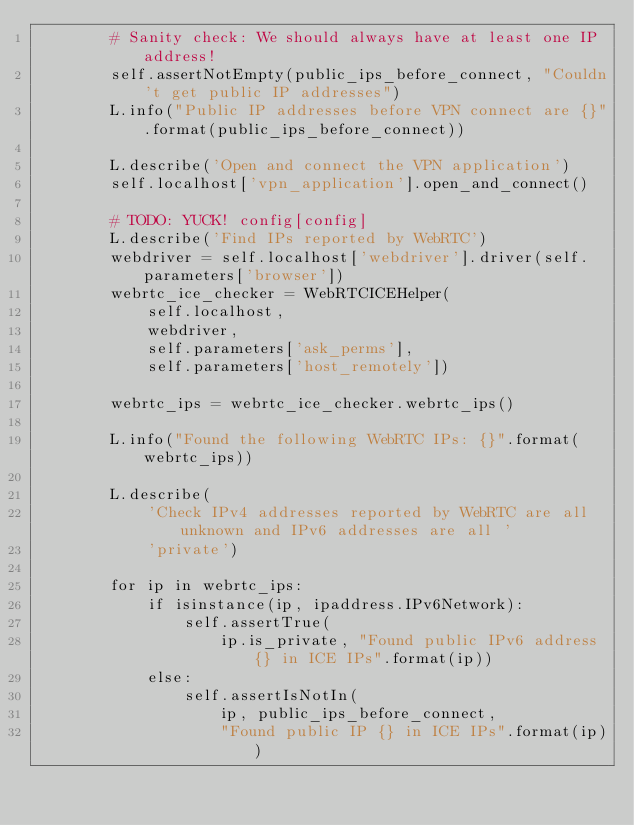Convert code to text. <code><loc_0><loc_0><loc_500><loc_500><_Python_>        # Sanity check: We should always have at least one IP address!
        self.assertNotEmpty(public_ips_before_connect, "Couldn't get public IP addresses")
        L.info("Public IP addresses before VPN connect are {}".format(public_ips_before_connect))

        L.describe('Open and connect the VPN application')
        self.localhost['vpn_application'].open_and_connect()

        # TODO: YUCK! config[config]
        L.describe('Find IPs reported by WebRTC')
        webdriver = self.localhost['webdriver'].driver(self.parameters['browser'])
        webrtc_ice_checker = WebRTCICEHelper(
            self.localhost,
            webdriver,
            self.parameters['ask_perms'],
            self.parameters['host_remotely'])

        webrtc_ips = webrtc_ice_checker.webrtc_ips()

        L.info("Found the following WebRTC IPs: {}".format(webrtc_ips))

        L.describe(
            'Check IPv4 addresses reported by WebRTC are all unknown and IPv6 addresses are all '
            'private')

        for ip in webrtc_ips:
            if isinstance(ip, ipaddress.IPv6Network):
                self.assertTrue(
                    ip.is_private, "Found public IPv6 address {} in ICE IPs".format(ip))
            else:
                self.assertIsNotIn(
                    ip, public_ips_before_connect,
                    "Found public IP {} in ICE IPs".format(ip))
</code> 